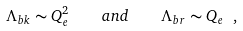Convert formula to latex. <formula><loc_0><loc_0><loc_500><loc_500>\Lambda _ { b k } \sim Q _ { e } ^ { 2 } \quad a n d \quad \Lambda _ { b r } \sim Q _ { e } \ ,</formula> 